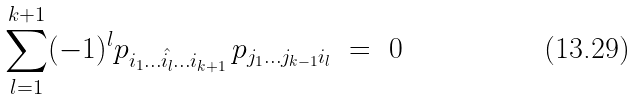Convert formula to latex. <formula><loc_0><loc_0><loc_500><loc_500>\sum _ { l = 1 } ^ { k + 1 } ( - 1 ) ^ { l } p _ { i _ { 1 } \dots \hat { i _ { l } } \dots i _ { k + 1 } } \, p _ { j _ { 1 } \dots j _ { k - 1 } i _ { l } } \ = \ 0</formula> 